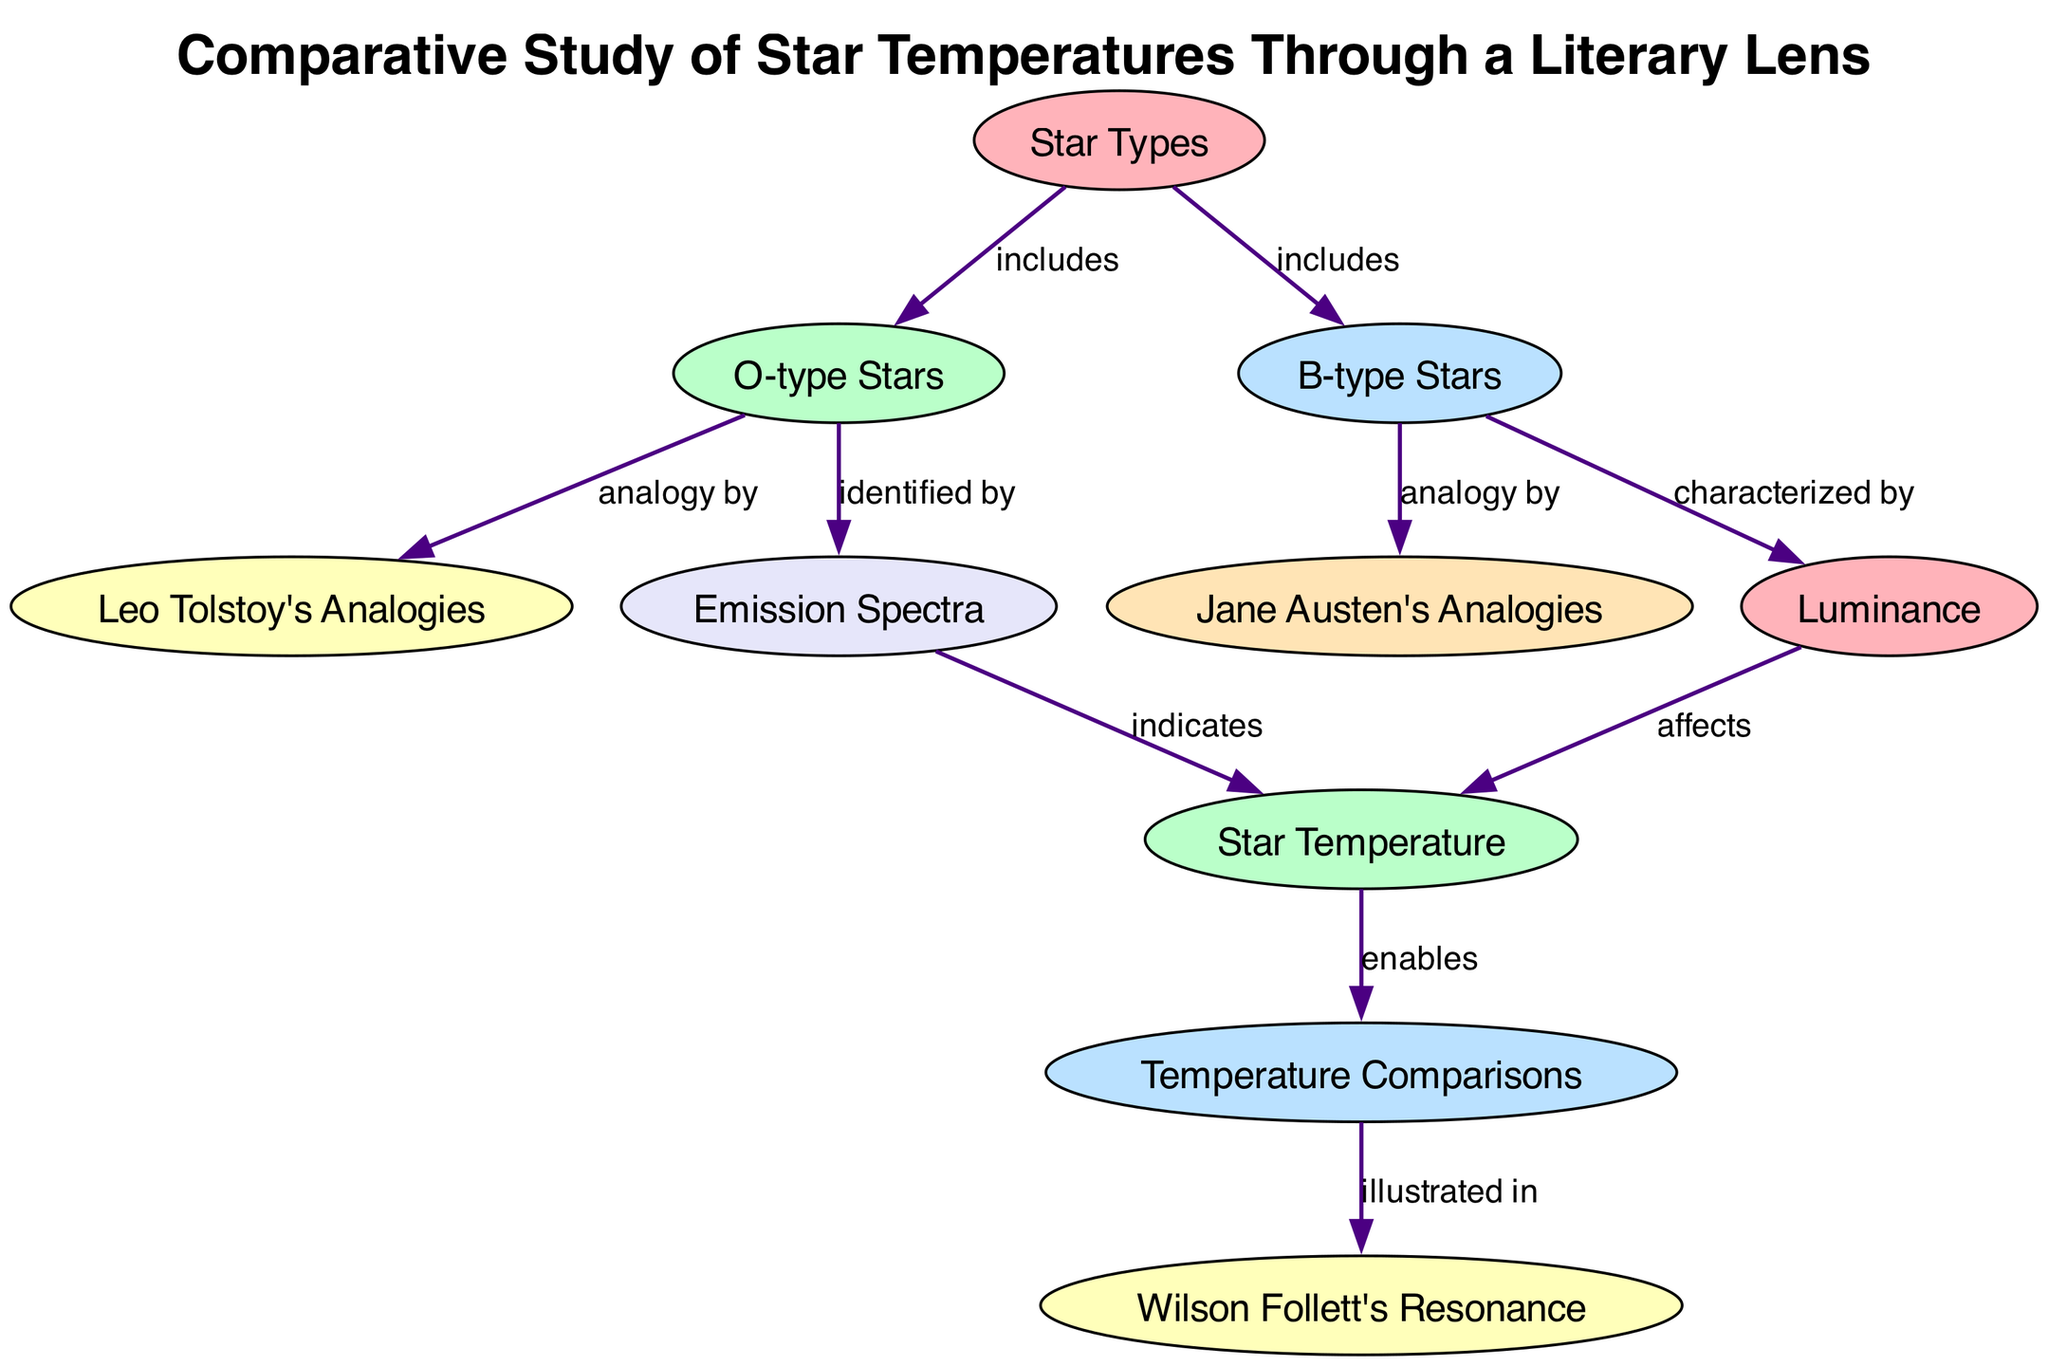What are the two types of stars included in the diagram? The diagram includes O-type Stars and B-type Stars as defined under the "Star Types" node.
Answer: O-type Stars, B-type Stars What analogy is linked to O-type Stars? The diagram indicates that the analogy for O-type Stars is by Leo Tolstoy, as shown by the edge from O-type Stars to the node for Tolstoy's analogies.
Answer: Leo Tolstoy's Analogies What does the Emission Spectra indicate about star temperatures? According to the diagram, the Emission Spectra indicates Star Temperature, which establishes a direct relationship evidenced by the edge connecting these two nodes.
Answer: Star Temperature Which aspect is characterized by B-type Stars? The relationship in the diagram shows that B-type Stars are characterized by Luminance, as indicated by the edge linking these two particular nodes.
Answer: Luminance How many total nodes are present in the diagram? By counting the nodes listed in the diagram, we find eight unique nodes present throughout.
Answer: Eight What does Star Temperature enable in the context of the diagram? The diagram depicts that Star Temperature enables Temperature Comparisons, as highlighted by the outbound edge from Star Temperature to Temp Comparisons.
Answer: Temperature Comparisons Who illustrates the Temperature Comparisons? The Temperature Comparisons are illustrated in Wilson Follett's Resonance, as per the directional edge connecting Temp Comparisons to the WT Resonance node.
Answer: Wilson Follett's Resonance What is the relationship between Star Temperature and Luminance? The diagram states that Luminance affects Star Temperature, creating a causal relationship evident through the edge connecting the two concepts.
Answer: Affects What is the relationship between B-type Stars and Luminance? The relationship shown indicates that B-type Stars are characterized by Luminance, which is explicitly represented in the diagram by an edge from B-type Stars to the Luminance node.
Answer: Characterized by 